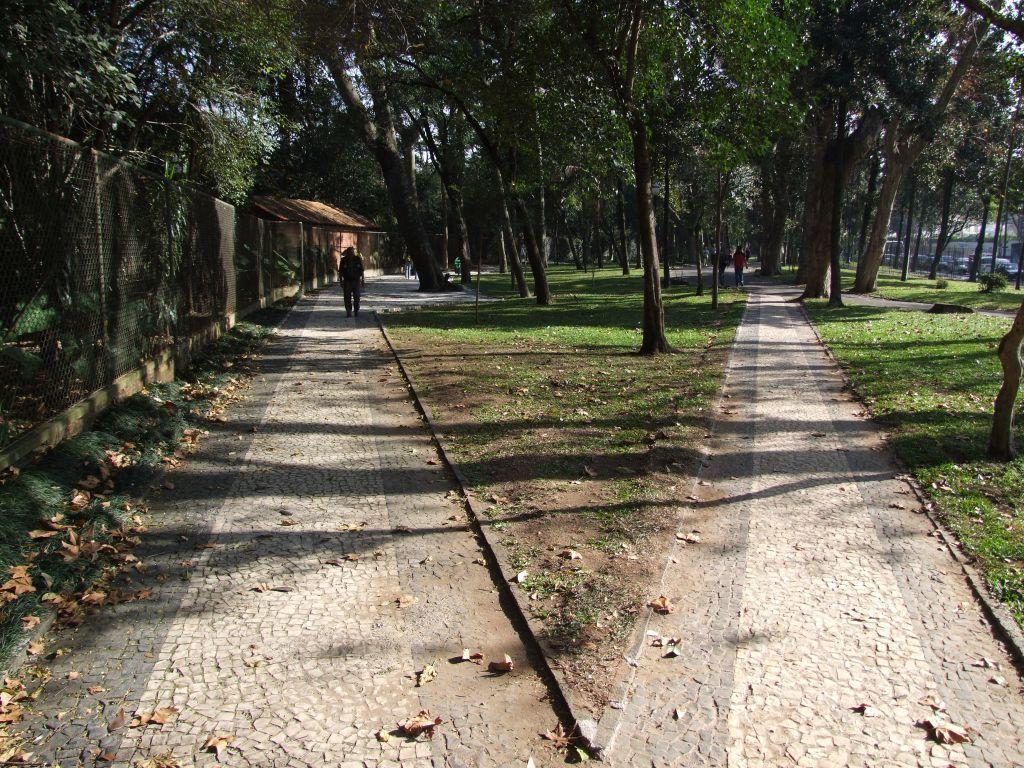How would you summarize this image in a sentence or two? In the foreground of this image, there are two paths and the lawns. On the left, there is fencing. In the background, there are few people walking on the path and we can also see trees, a hut and few vehicles moving on the right. 